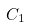Convert formula to latex. <formula><loc_0><loc_0><loc_500><loc_500>C _ { 1 }</formula> 